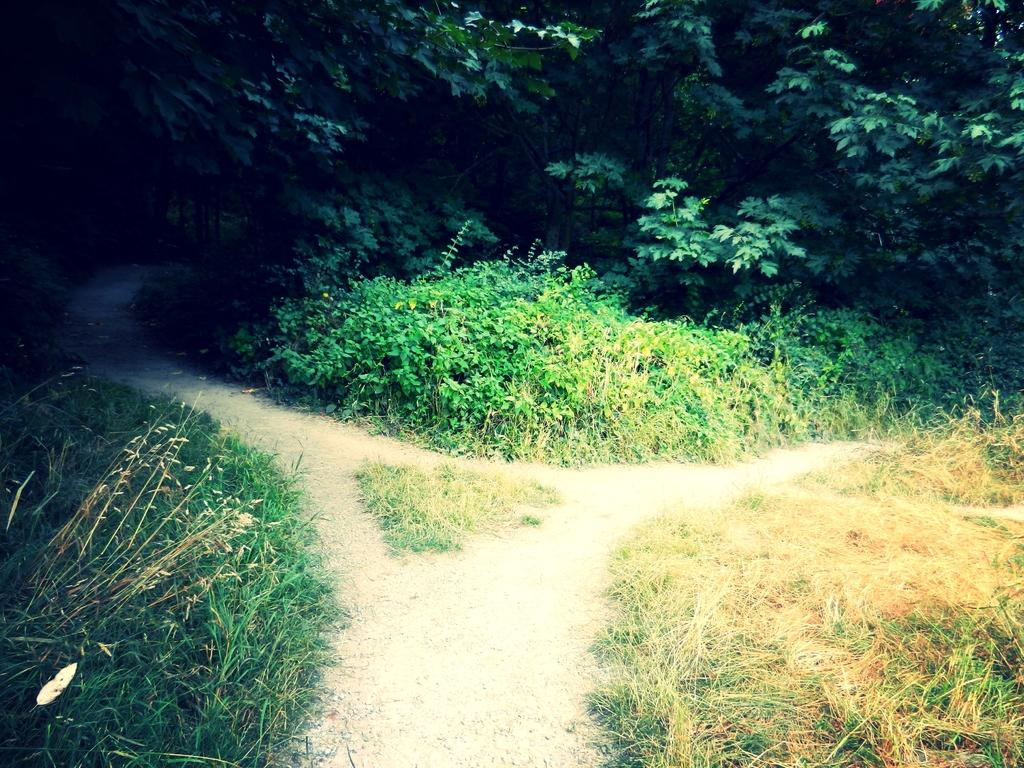What type of path is visible in the image? There is a walkway in the image. What can be seen around the walkway? Plants, grass, and trees are present around the walkway. Can you describe the vegetation around the walkway? The vegetation includes plants, grass, and trees. What is the tendency of the scissors to fly in the image? There are no scissors present in the image, so it is not possible to determine their tendency to fly. 